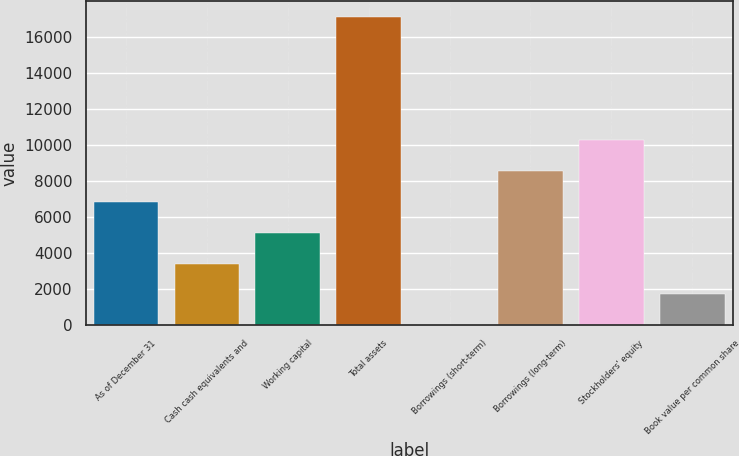<chart> <loc_0><loc_0><loc_500><loc_500><bar_chart><fcel>As of December 31<fcel>Cash cash equivalents and<fcel>Working capital<fcel>Total assets<fcel>Borrowings (short-term)<fcel>Borrowings (long-term)<fcel>Stockholders' equity<fcel>Book value per common share<nl><fcel>6856.8<fcel>3430.4<fcel>5143.6<fcel>17136<fcel>4<fcel>8570<fcel>10283.2<fcel>1717.2<nl></chart> 